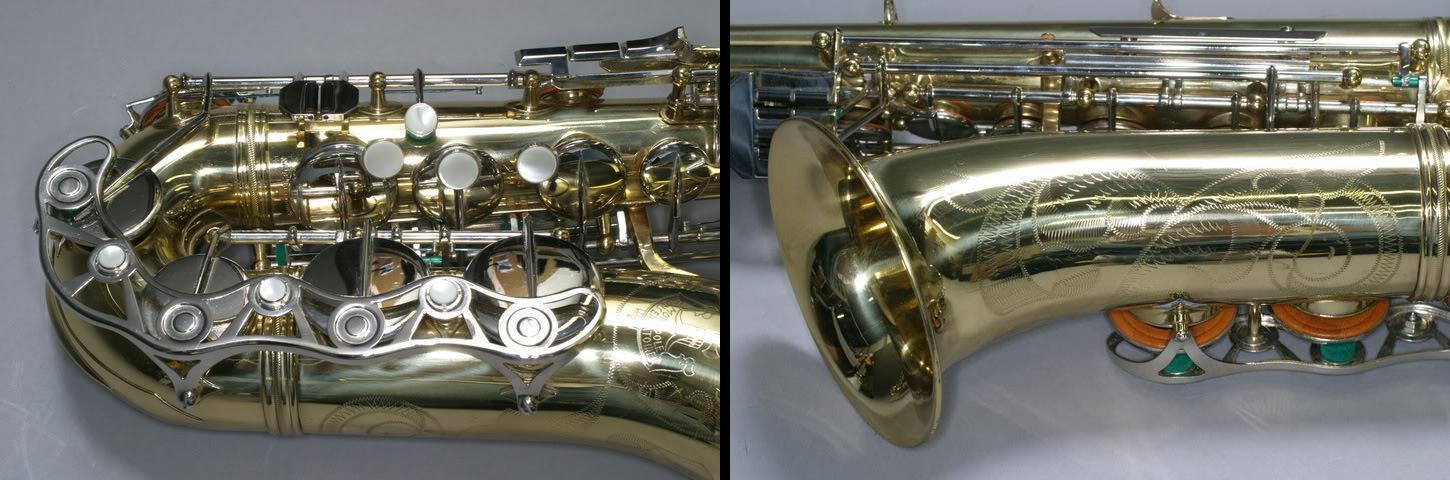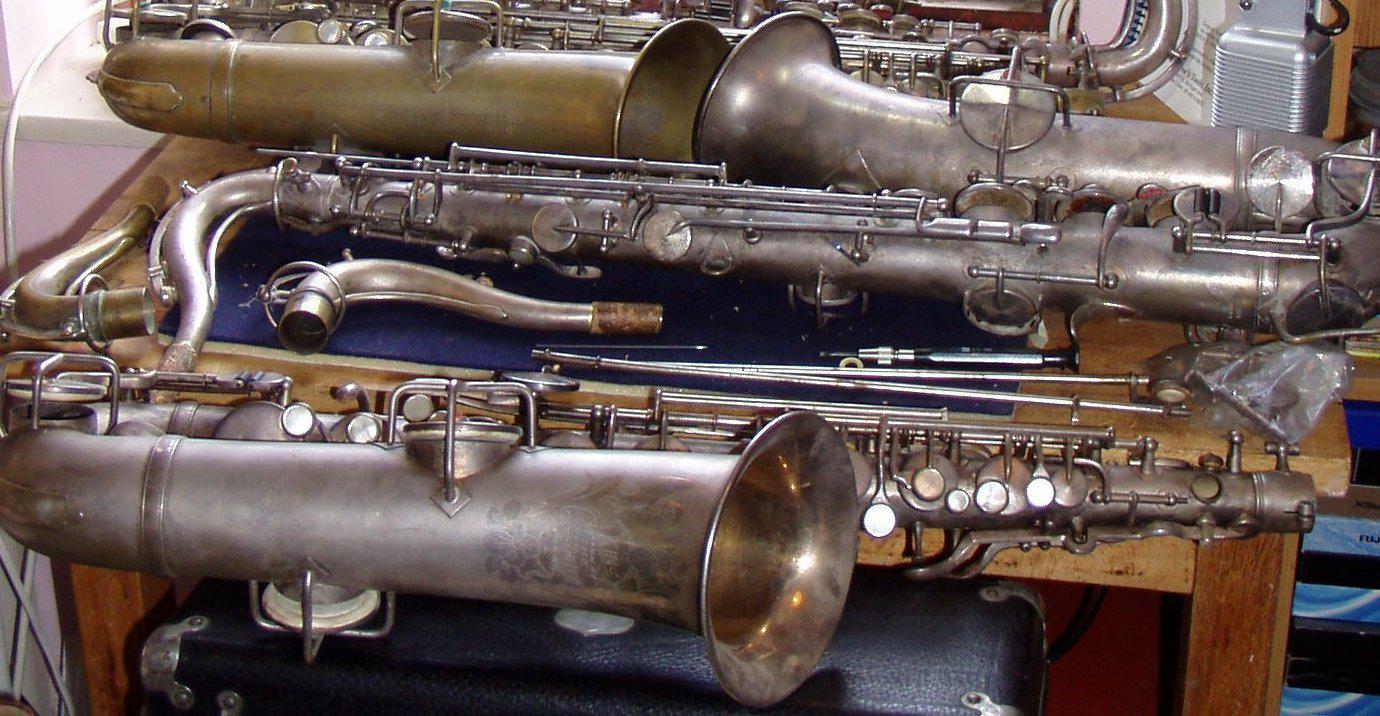The first image is the image on the left, the second image is the image on the right. Given the left and right images, does the statement "The fabric underneath the instruments in one image is red." hold true? Answer yes or no. No. The first image is the image on the left, the second image is the image on the right. Analyze the images presented: Is the assertion "The left image shows a saxophone displayed horizontally, with its bell facing downward and its attached mouthpiece facing upward at the right." valid? Answer yes or no. No. 